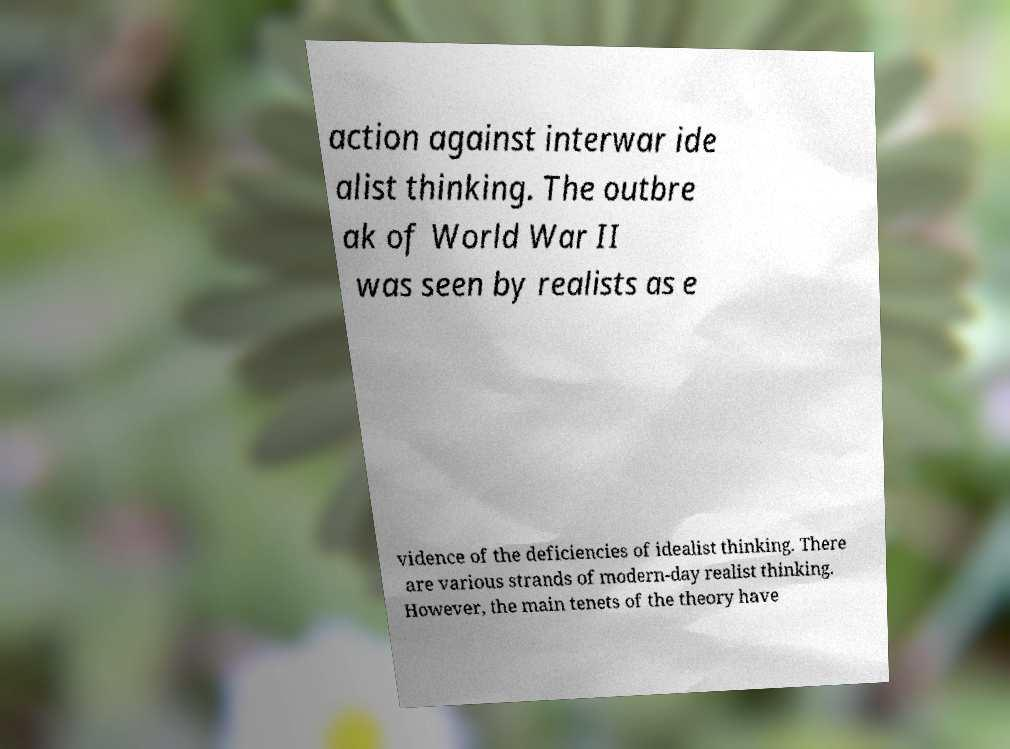Please identify and transcribe the text found in this image. The image contains a piece of paper with the following text: 'action against interwar idealist thinking. The outbreak of World War II was seen by realists as evidence of the deficiencies of idealist thinking. There are various strands of modern-day realist thinking. However, the main tenets of the theory have...' Unfortunately, the text is incomplete as the image does not show the full paper, so we cannot determine the end of the sentence. 